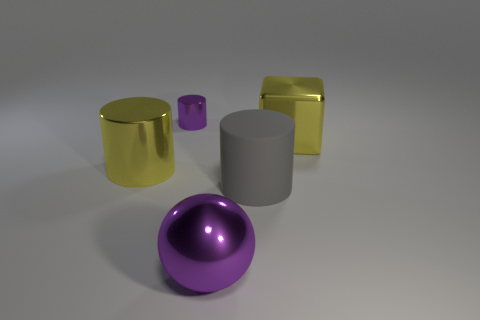How many cyan things are shiny spheres or metal objects?
Provide a short and direct response. 0. Is the purple object that is in front of the block made of the same material as the tiny purple cylinder?
Offer a very short reply. Yes. How many other objects are the same material as the tiny purple object?
Offer a very short reply. 3. What is the big yellow cube made of?
Keep it short and to the point. Metal. What size is the shiny cylinder in front of the tiny purple thing?
Provide a succinct answer. Large. There is a yellow shiny thing that is right of the big purple object; what number of purple objects are in front of it?
Keep it short and to the point. 1. Do the large yellow thing on the left side of the big gray object and the purple object that is behind the purple shiny ball have the same shape?
Provide a short and direct response. Yes. How many things are in front of the big metal block and to the left of the purple metal sphere?
Your response must be concise. 1. Is there a tiny shiny cylinder of the same color as the metal sphere?
Ensure brevity in your answer.  Yes. What is the shape of the matte thing that is the same size as the metal cube?
Give a very brief answer. Cylinder. 